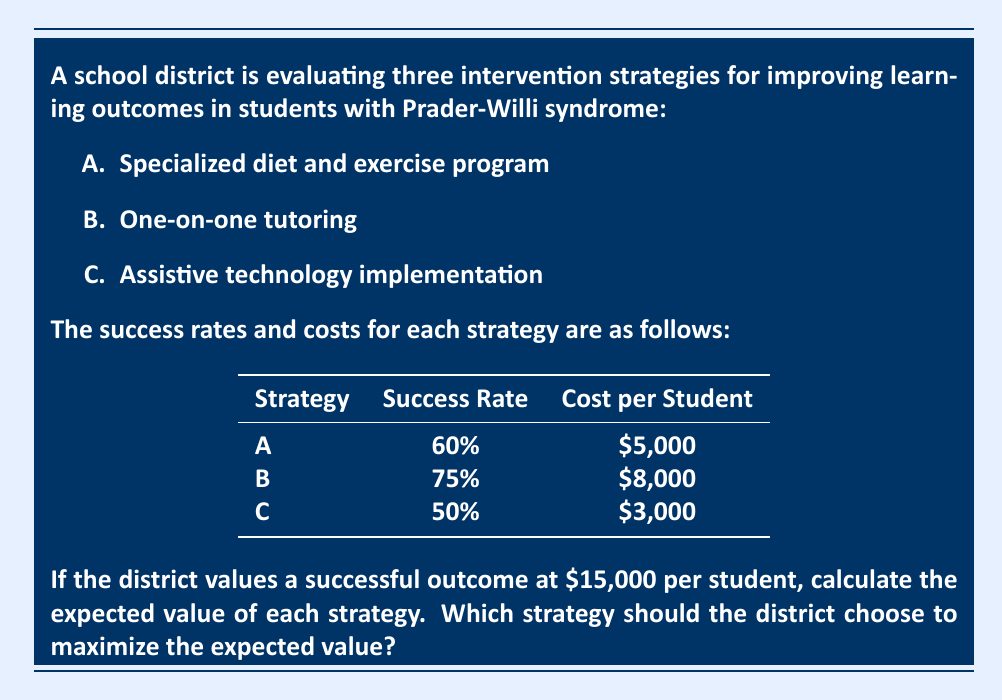Help me with this question. To solve this problem, we need to calculate the expected value for each strategy using the formula:

$$ EV = (P_{success} \times V_{success}) - C_{strategy} $$

Where:
$EV$ = Expected Value
$P_{success}$ = Probability of Success
$V_{success}$ = Value of Success
$C_{strategy}$ = Cost of Strategy

Let's calculate the expected value for each strategy:

1. Strategy A:
$$ EV_A = (0.60 \times \$15,000) - \$5,000 = \$9,000 - \$5,000 = \$4,000 $$

2. Strategy B:
$$ EV_B = (0.75 \times \$15,000) - \$8,000 = \$11,250 - \$8,000 = \$3,250 $$

3. Strategy C:
$$ EV_C = (0.50 \times \$15,000) - \$3,000 = \$7,500 - \$3,000 = \$4,500 $$

Comparing the expected values:

$EV_A = \$4,000$
$EV_B = \$3,250$
$EV_C = \$4,500$

Strategy C has the highest expected value, so the district should choose this strategy to maximize the expected value.
Answer: Strategy C: Assistive technology implementation ($4,500) 